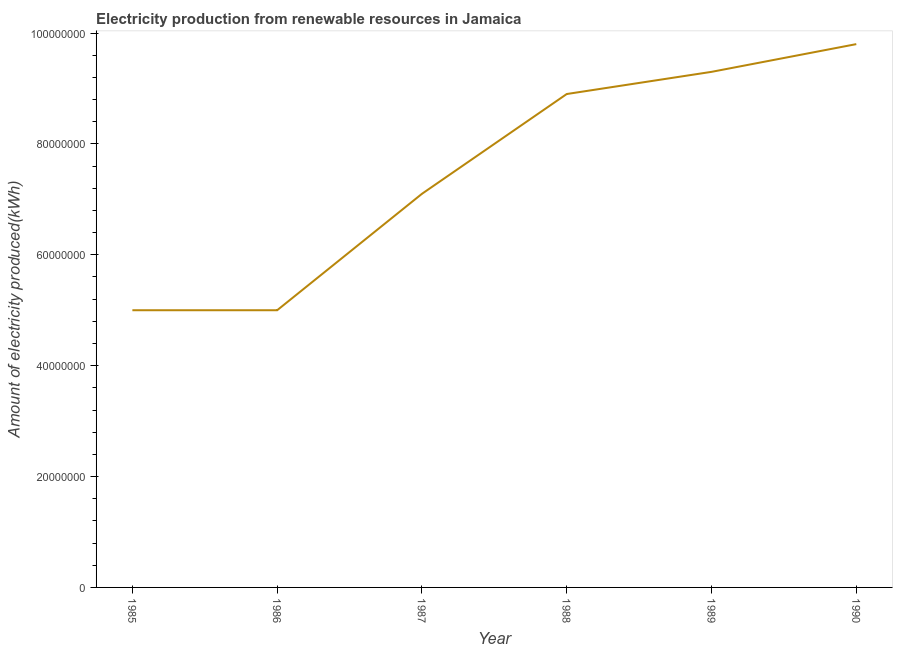What is the amount of electricity produced in 1989?
Provide a succinct answer. 9.30e+07. Across all years, what is the maximum amount of electricity produced?
Make the answer very short. 9.80e+07. Across all years, what is the minimum amount of electricity produced?
Keep it short and to the point. 5.00e+07. In which year was the amount of electricity produced maximum?
Provide a short and direct response. 1990. What is the sum of the amount of electricity produced?
Give a very brief answer. 4.51e+08. What is the difference between the amount of electricity produced in 1985 and 1987?
Give a very brief answer. -2.10e+07. What is the average amount of electricity produced per year?
Give a very brief answer. 7.52e+07. What is the median amount of electricity produced?
Provide a succinct answer. 8.00e+07. In how many years, is the amount of electricity produced greater than 72000000 kWh?
Give a very brief answer. 3. Do a majority of the years between 1986 and 1989 (inclusive) have amount of electricity produced greater than 88000000 kWh?
Your response must be concise. No. What is the ratio of the amount of electricity produced in 1986 to that in 1989?
Keep it short and to the point. 0.54. What is the difference between the highest and the lowest amount of electricity produced?
Provide a short and direct response. 4.80e+07. In how many years, is the amount of electricity produced greater than the average amount of electricity produced taken over all years?
Give a very brief answer. 3. Does the amount of electricity produced monotonically increase over the years?
Your answer should be very brief. No. Are the values on the major ticks of Y-axis written in scientific E-notation?
Make the answer very short. No. Does the graph contain any zero values?
Offer a very short reply. No. What is the title of the graph?
Your answer should be very brief. Electricity production from renewable resources in Jamaica. What is the label or title of the Y-axis?
Your response must be concise. Amount of electricity produced(kWh). What is the Amount of electricity produced(kWh) of 1985?
Provide a short and direct response. 5.00e+07. What is the Amount of electricity produced(kWh) of 1987?
Give a very brief answer. 7.10e+07. What is the Amount of electricity produced(kWh) of 1988?
Give a very brief answer. 8.90e+07. What is the Amount of electricity produced(kWh) in 1989?
Your answer should be very brief. 9.30e+07. What is the Amount of electricity produced(kWh) of 1990?
Your answer should be compact. 9.80e+07. What is the difference between the Amount of electricity produced(kWh) in 1985 and 1986?
Offer a very short reply. 0. What is the difference between the Amount of electricity produced(kWh) in 1985 and 1987?
Make the answer very short. -2.10e+07. What is the difference between the Amount of electricity produced(kWh) in 1985 and 1988?
Keep it short and to the point. -3.90e+07. What is the difference between the Amount of electricity produced(kWh) in 1985 and 1989?
Provide a succinct answer. -4.30e+07. What is the difference between the Amount of electricity produced(kWh) in 1985 and 1990?
Make the answer very short. -4.80e+07. What is the difference between the Amount of electricity produced(kWh) in 1986 and 1987?
Your answer should be compact. -2.10e+07. What is the difference between the Amount of electricity produced(kWh) in 1986 and 1988?
Your answer should be compact. -3.90e+07. What is the difference between the Amount of electricity produced(kWh) in 1986 and 1989?
Give a very brief answer. -4.30e+07. What is the difference between the Amount of electricity produced(kWh) in 1986 and 1990?
Keep it short and to the point. -4.80e+07. What is the difference between the Amount of electricity produced(kWh) in 1987 and 1988?
Offer a very short reply. -1.80e+07. What is the difference between the Amount of electricity produced(kWh) in 1987 and 1989?
Offer a very short reply. -2.20e+07. What is the difference between the Amount of electricity produced(kWh) in 1987 and 1990?
Your response must be concise. -2.70e+07. What is the difference between the Amount of electricity produced(kWh) in 1988 and 1990?
Offer a very short reply. -9.00e+06. What is the difference between the Amount of electricity produced(kWh) in 1989 and 1990?
Ensure brevity in your answer.  -5.00e+06. What is the ratio of the Amount of electricity produced(kWh) in 1985 to that in 1987?
Offer a very short reply. 0.7. What is the ratio of the Amount of electricity produced(kWh) in 1985 to that in 1988?
Ensure brevity in your answer.  0.56. What is the ratio of the Amount of electricity produced(kWh) in 1985 to that in 1989?
Your answer should be very brief. 0.54. What is the ratio of the Amount of electricity produced(kWh) in 1985 to that in 1990?
Offer a terse response. 0.51. What is the ratio of the Amount of electricity produced(kWh) in 1986 to that in 1987?
Ensure brevity in your answer.  0.7. What is the ratio of the Amount of electricity produced(kWh) in 1986 to that in 1988?
Offer a terse response. 0.56. What is the ratio of the Amount of electricity produced(kWh) in 1986 to that in 1989?
Your response must be concise. 0.54. What is the ratio of the Amount of electricity produced(kWh) in 1986 to that in 1990?
Make the answer very short. 0.51. What is the ratio of the Amount of electricity produced(kWh) in 1987 to that in 1988?
Give a very brief answer. 0.8. What is the ratio of the Amount of electricity produced(kWh) in 1987 to that in 1989?
Make the answer very short. 0.76. What is the ratio of the Amount of electricity produced(kWh) in 1987 to that in 1990?
Provide a short and direct response. 0.72. What is the ratio of the Amount of electricity produced(kWh) in 1988 to that in 1990?
Provide a short and direct response. 0.91. What is the ratio of the Amount of electricity produced(kWh) in 1989 to that in 1990?
Your answer should be very brief. 0.95. 